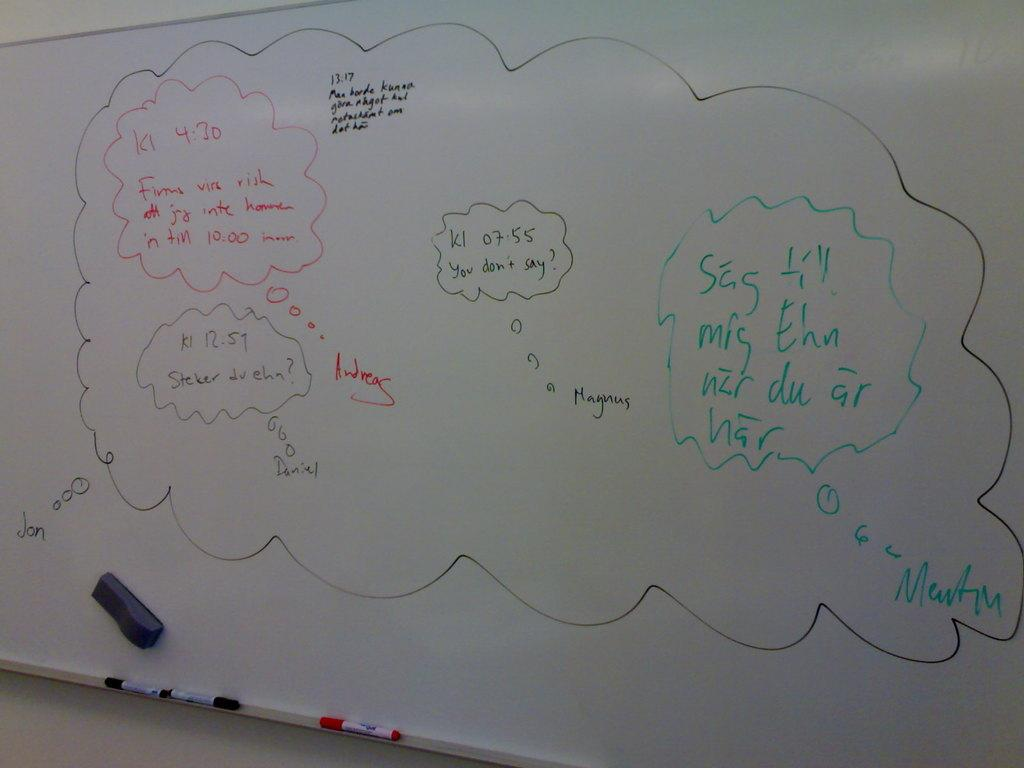<image>
Provide a brief description of the given image. A whiteboard has you don't say? written on it in black. 